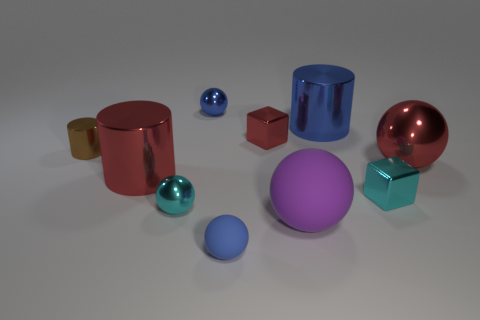Can you describe the arrangement of objects and what it might suggest about balance and symmetry? The objects are scattered asymmetrically with varying distances between them, which creates a casual and natural feeling in the scene. There's no distinct pattern or symmetry, suggesting a more spontaneous composition rather than a carefully balanced one. Does the purple sphere play a significant role in the composition? Yes, the large purple sphere acts as a focal point due to its size and central positioning. It anchors the composition, and its vibrant color attracts the eye, making it significant in the visual hierarchy of the scene. 